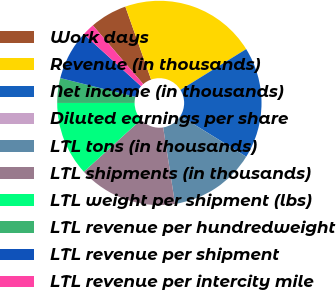<chart> <loc_0><loc_0><loc_500><loc_500><pie_chart><fcel>Work days<fcel>Revenue (in thousands)<fcel>Net income (in thousands)<fcel>Diluted earnings per share<fcel>LTL tons (in thousands)<fcel>LTL shipments (in thousands)<fcel>LTL weight per shipment (lbs)<fcel>LTL revenue per hundredweight<fcel>LTL revenue per shipment<fcel>LTL revenue per intercity mile<nl><fcel>5.88%<fcel>21.57%<fcel>17.65%<fcel>0.0%<fcel>13.73%<fcel>15.69%<fcel>11.76%<fcel>3.92%<fcel>7.84%<fcel>1.96%<nl></chart> 